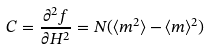<formula> <loc_0><loc_0><loc_500><loc_500>C = \frac { \partial ^ { 2 } f } { \partial H ^ { 2 } } = N ( \langle m ^ { 2 } \rangle - \langle m \rangle ^ { 2 } )</formula> 